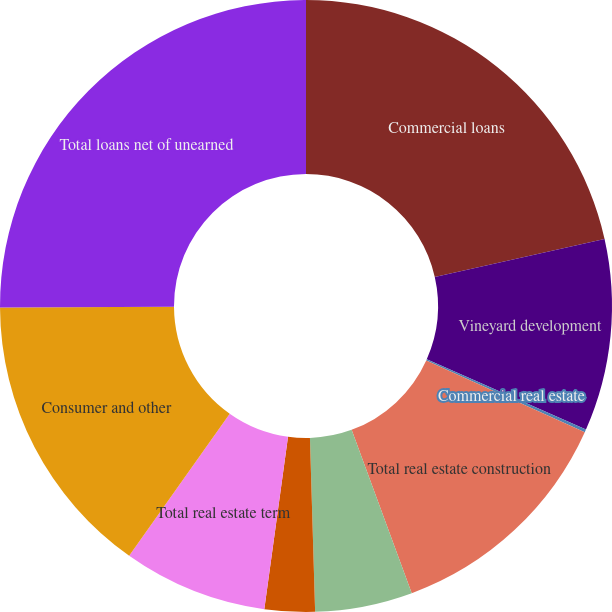Convert chart to OTSL. <chart><loc_0><loc_0><loc_500><loc_500><pie_chart><fcel>Commercial loans<fcel>Vineyard development<fcel>Commercial real estate<fcel>Total real estate construction<fcel>Real estate term-consumer<fcel>Real estate term-commercial<fcel>Total real estate term<fcel>Consumer and other<fcel>Total loans net of unearned<nl><fcel>21.48%<fcel>10.13%<fcel>0.15%<fcel>12.62%<fcel>5.14%<fcel>2.65%<fcel>7.63%<fcel>15.11%<fcel>25.08%<nl></chart> 